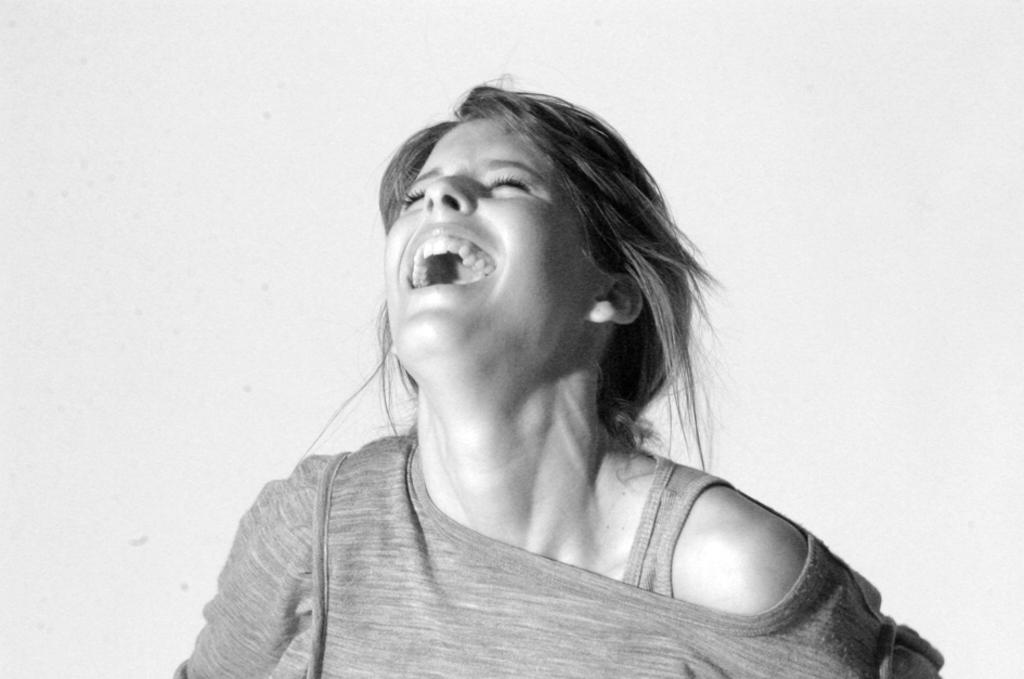What is the color scheme of the image? The image is black and white. Who is present in the image? There is a woman in the image. What is the woman doing in the image? The woman is smiling. What type of pancake is the woman flipping in the image? There is no pancake present in the image; it is a black and white image of a woman smiling. 